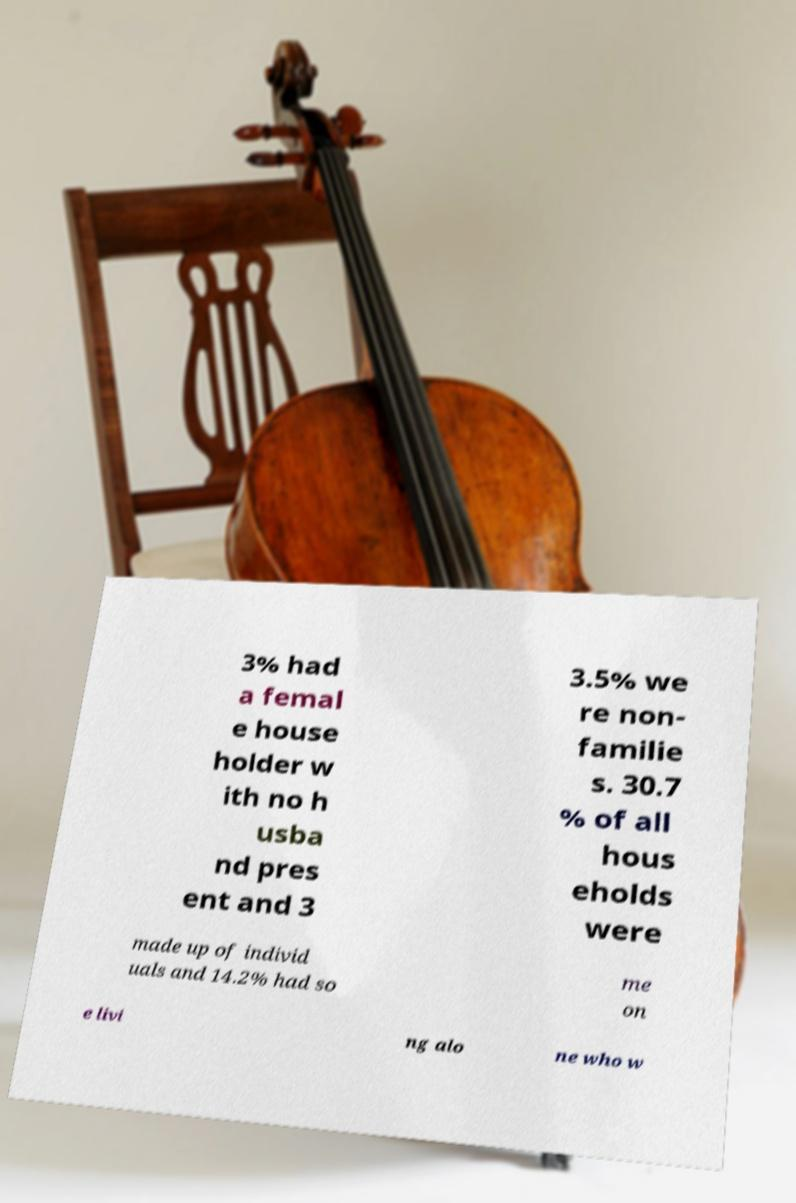Please read and relay the text visible in this image. What does it say? 3% had a femal e house holder w ith no h usba nd pres ent and 3 3.5% we re non- familie s. 30.7 % of all hous eholds were made up of individ uals and 14.2% had so me on e livi ng alo ne who w 